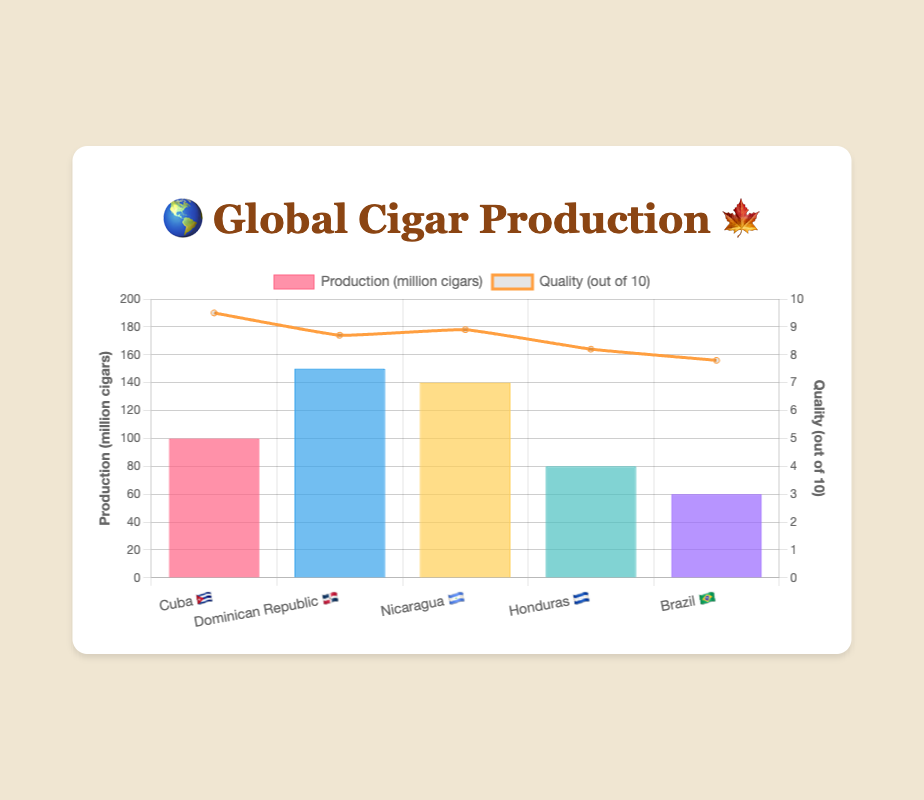Which country has the highest cigar production? To find the country with the highest cigar production, look at the bar corresponding to each country and compare their heights. The Dominican Republic 🇩🇴 has the tallest bar.
Answer: Dominican Republic 🇩🇴 What is the quality rating for cigars from Cuba 🇨🇺? To find the quality rating for cigars from Cuba, look at the line chart corresponding to Cuba 🇨🇺. The point for Cuba 🇨🇺 is at 9.5.
Answer: 9.5 Which country has the lowest cigar quality rating? To determine the country with the lowest cigar quality rating, compare the line chart for each country’s quality. Brazil 🇧🇷 has the lowest point on the line chart, which is 7.8.
Answer: Brazil 🇧🇷 How much higher is the production of cigars in Nicaragua 🇳🇮 compared to Honduras 🇭🇳? To calculate how much higher Nicaragua's production is compared to Honduras, subtract the production of Honduras from Nicaragua. Nicaragua 🇳🇮 produces 140 million cigars, and Honduras 🇭🇳 produces 80 million cigars. Thus, 140 - 80 = 60 million cigars.
Answer: 60 million cigars Which country has higher cigar quality, the Dominican Republic 🇩🇴 or Nicaragua 🇳🇮? To determine which country has a higher cigar quality, compare the quality ratings from the line chart. The Dominican Republic 🇩🇴 has a rating of 8.7, while Nicaragua 🇳🇮 has 8.9. Thus, Nicaragua 🇳🇮 has a higher quality rating.
Answer: Nicaragua 🇳🇮 What is the total production of cigars among all the countries shown? To find the total production, sum up the production values for all countries: Cuba 🇨🇺 (100 million), Dominican Republic 🇩🇴 (150 million), Nicaragua 🇳🇮 (140 million), Honduras 🇭🇳 (80 million), and Brazil 🇧🇷 (60 million). So, 100 + 150 + 140 + 80 + 60 = 530 million cigars.
Answer: 530 million cigars Is the quality of cigars from Honduras 🌱 above or below 8? To determine if the quality rating for cigars from Honduras is above or below 8, check the line chart for Honduras 🇭🇳. The point for Honduras 🇭🇳 is at 8.2, which is above 8.
Answer: Above Which country has the second highest quality rating for cigars? To find the second highest quality rating, check the line chart for each country. The highest is Cuba 🇨🇺 with 9.5, and the second highest is Nicaragua 🇳🇮 with 8.9.
Answer: Nicaragua 🇳🇮 What is the average quality rating of cigars from all the countries? To find the average quality rating, sum up all the quality ratings and divide by the number of countries. The sum is 9.5 (Cuba) + 8.7 (Dominican Republic) + 8.9 (Nicaragua) + 8.2 (Honduras) + 7.8 (Brazil) = 43.1. The number of countries is 5. So, the average is 43.1 / 5 = 8.62.
Answer: 8.62 